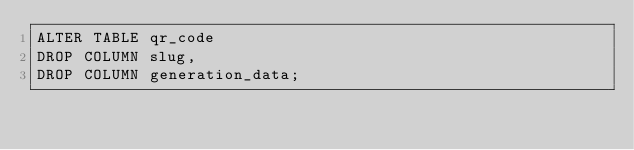Convert code to text. <code><loc_0><loc_0><loc_500><loc_500><_SQL_>ALTER TABLE qr_code
DROP COLUMN slug,
DROP COLUMN generation_data;
</code> 